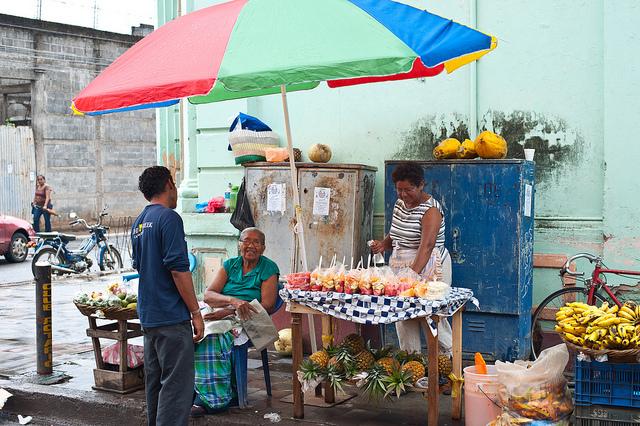What is on top of the blue rectangular stand?
Keep it brief. Squash. What colors are the umbrella?
Quick response, please. Red green blue yellow. What is the woman selling?
Answer briefly. Fruit. 